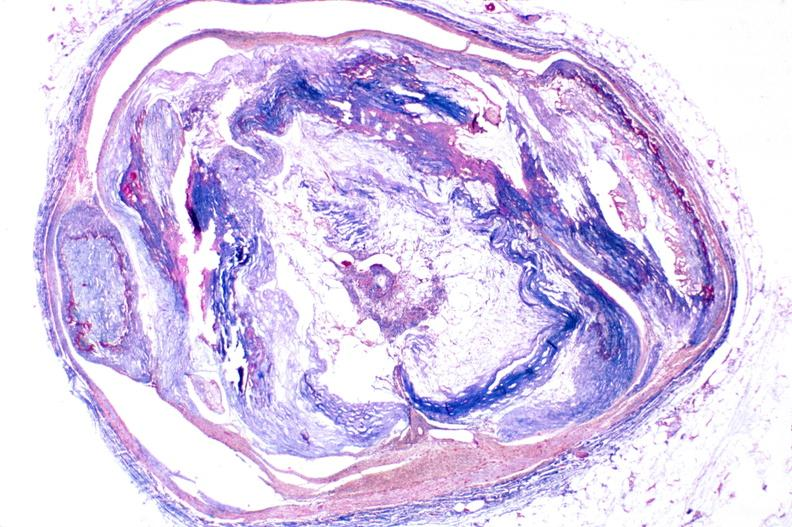s cardiovascular present?
Answer the question using a single word or phrase. Yes 